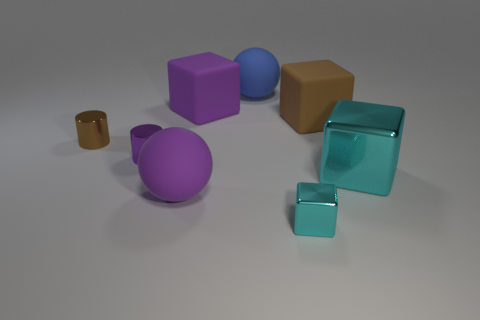Subtract 1 cubes. How many cubes are left? 3 Add 2 tiny cyan shiny spheres. How many objects exist? 10 Subtract all spheres. How many objects are left? 6 Subtract 1 purple cylinders. How many objects are left? 7 Subtract all small purple spheres. Subtract all blue balls. How many objects are left? 7 Add 8 brown objects. How many brown objects are left? 10 Add 6 blue rubber balls. How many blue rubber balls exist? 7 